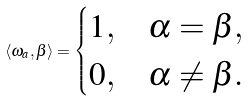Convert formula to latex. <formula><loc_0><loc_0><loc_500><loc_500>\langle \omega _ { a } , \beta \rangle = \begin{cases} 1 , & \alpha = \beta , \\ 0 , & \alpha \neq \beta . \end{cases}</formula> 